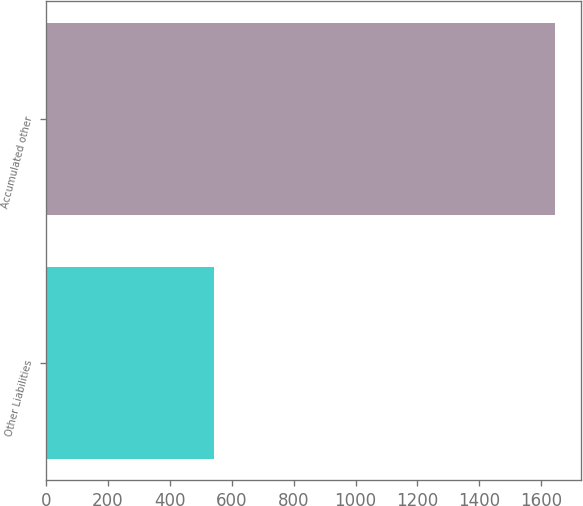Convert chart. <chart><loc_0><loc_0><loc_500><loc_500><bar_chart><fcel>Other Liabilities<fcel>Accumulated other<nl><fcel>544<fcel>1645<nl></chart> 